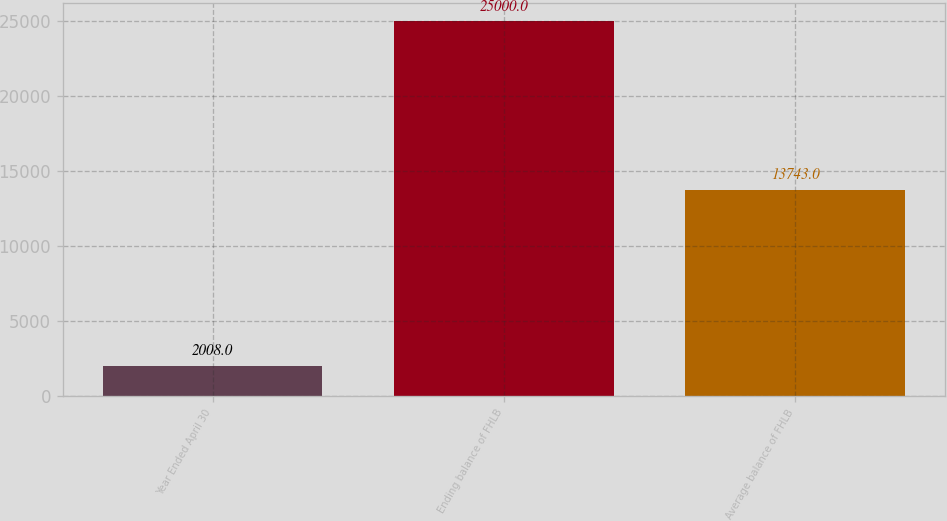<chart> <loc_0><loc_0><loc_500><loc_500><bar_chart><fcel>Year Ended April 30<fcel>Ending balance of FHLB<fcel>Average balance of FHLB<nl><fcel>2008<fcel>25000<fcel>13743<nl></chart> 